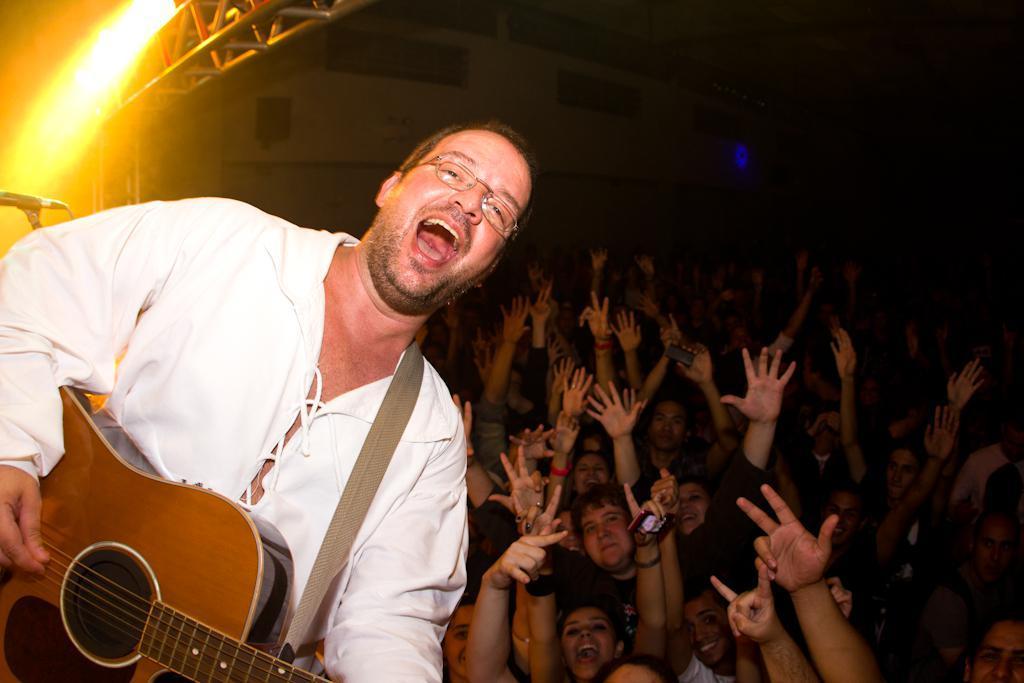How would you summarize this image in a sentence or two? In this image I can see the group of people among them the person on the left side is playing a guitar and smiling. 